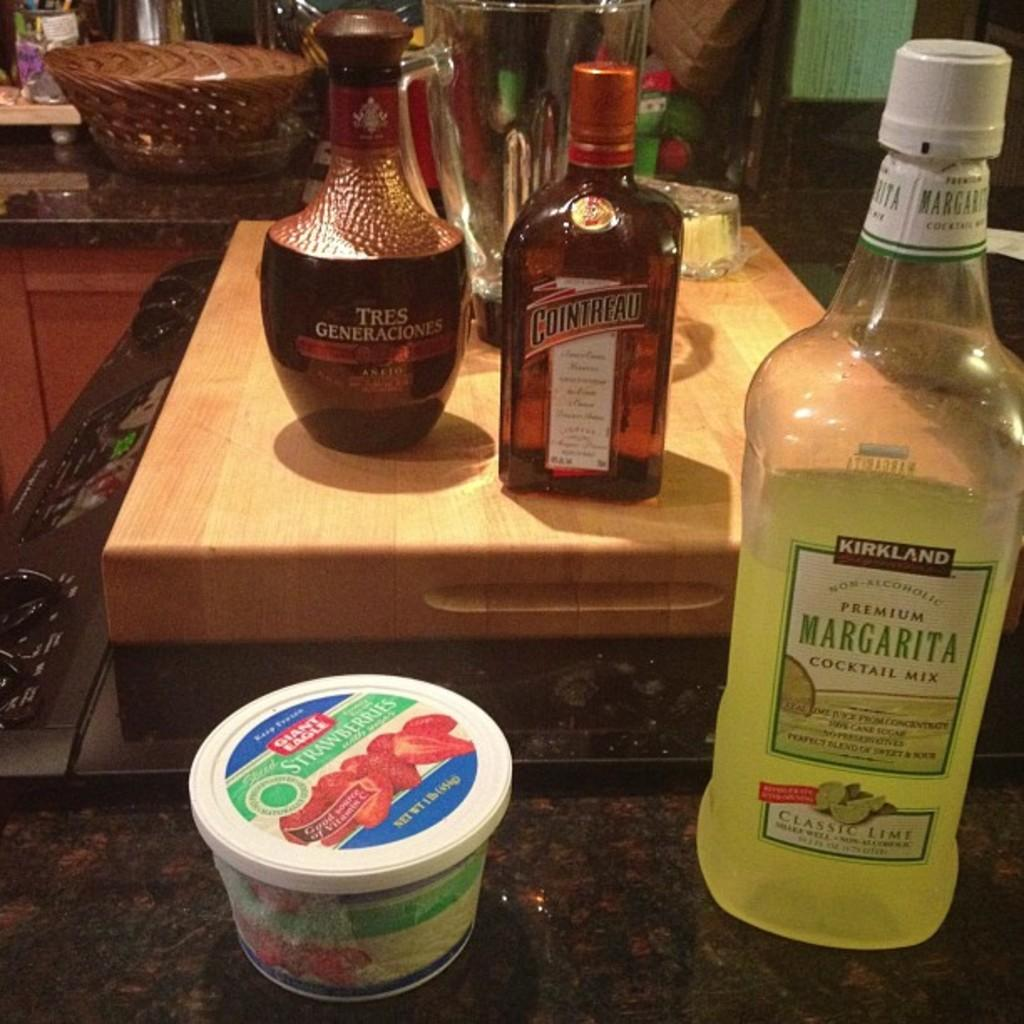Provide a one-sentence caption for the provided image. A bottle of Kirkland brand margarita sits next to a container of strawberries. 